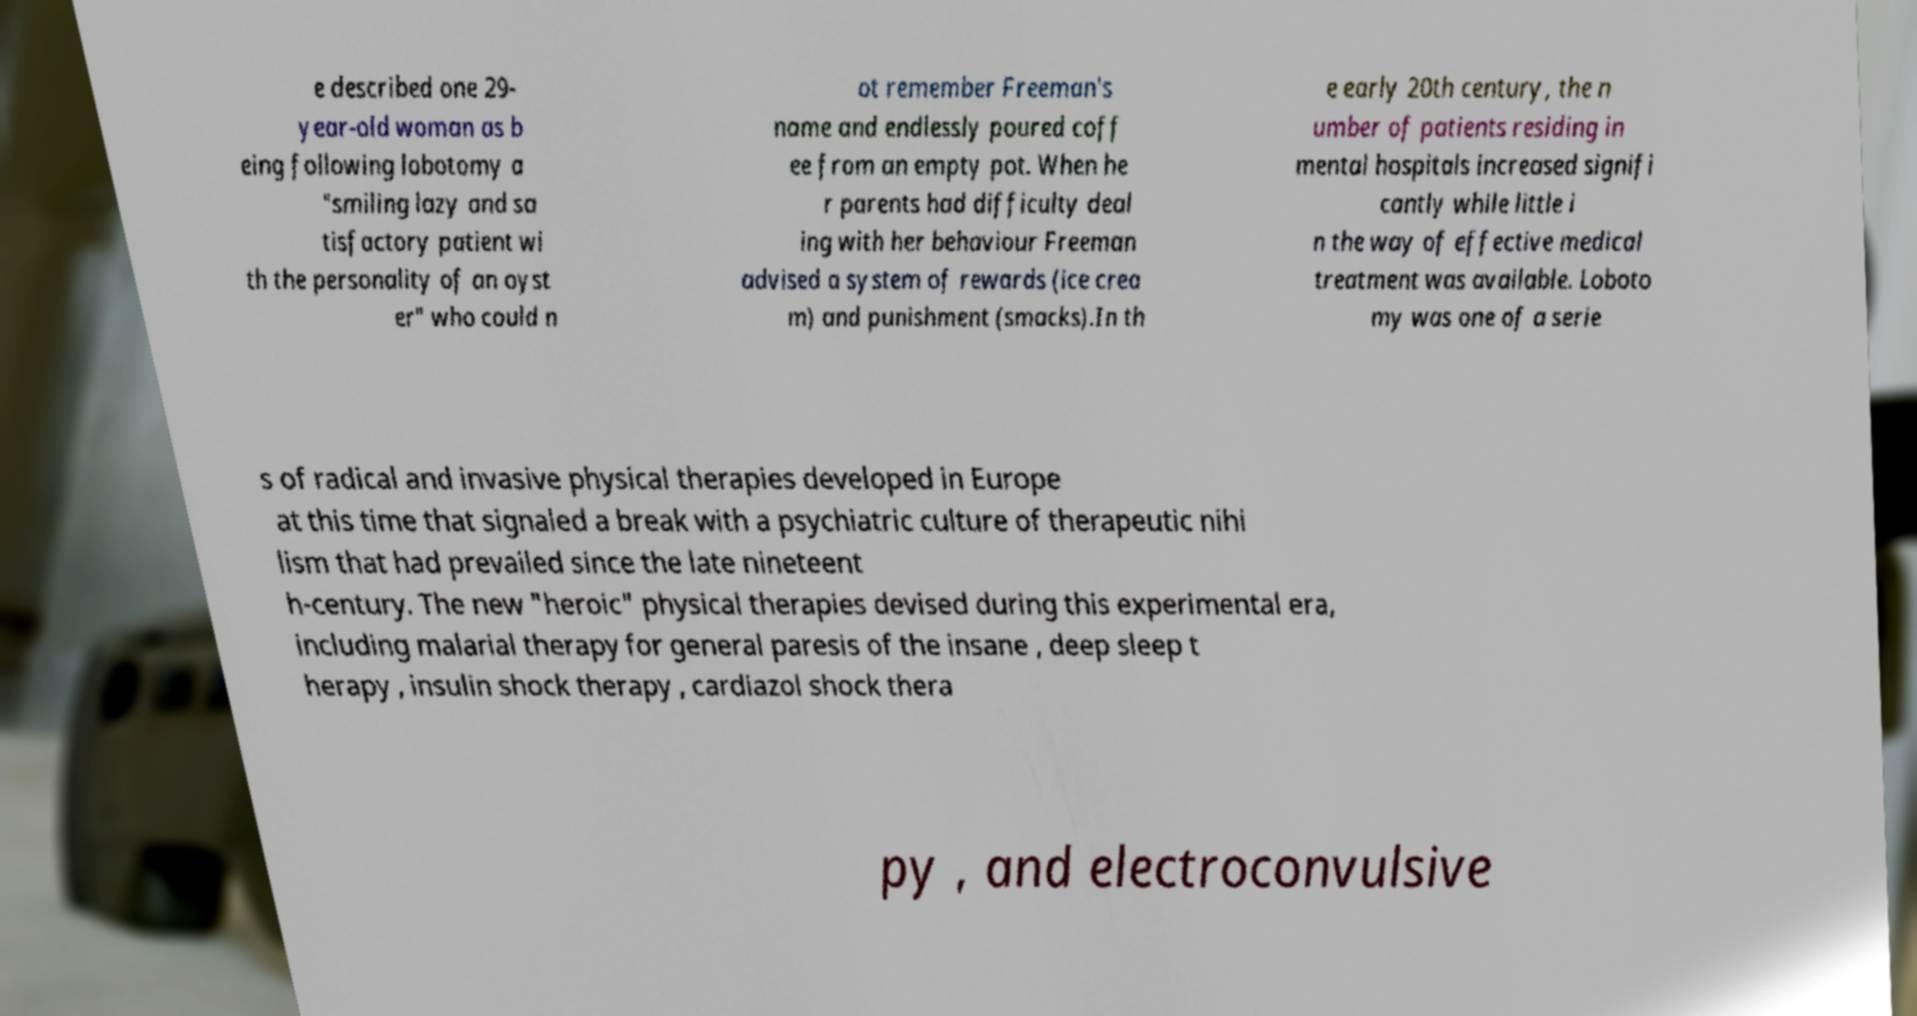Can you accurately transcribe the text from the provided image for me? e described one 29- year-old woman as b eing following lobotomy a "smiling lazy and sa tisfactory patient wi th the personality of an oyst er" who could n ot remember Freeman's name and endlessly poured coff ee from an empty pot. When he r parents had difficulty deal ing with her behaviour Freeman advised a system of rewards (ice crea m) and punishment (smacks).In th e early 20th century, the n umber of patients residing in mental hospitals increased signifi cantly while little i n the way of effective medical treatment was available. Loboto my was one of a serie s of radical and invasive physical therapies developed in Europe at this time that signaled a break with a psychiatric culture of therapeutic nihi lism that had prevailed since the late nineteent h-century. The new "heroic" physical therapies devised during this experimental era, including malarial therapy for general paresis of the insane , deep sleep t herapy , insulin shock therapy , cardiazol shock thera py , and electroconvulsive 